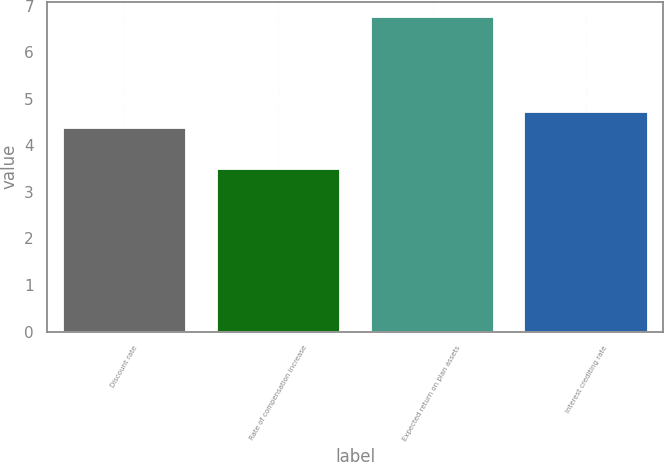<chart> <loc_0><loc_0><loc_500><loc_500><bar_chart><fcel>Discount rate<fcel>Rate of compensation increase<fcel>Expected return on plan assets<fcel>Interest crediting rate<nl><fcel>4.38<fcel>3.5<fcel>6.75<fcel>4.71<nl></chart> 